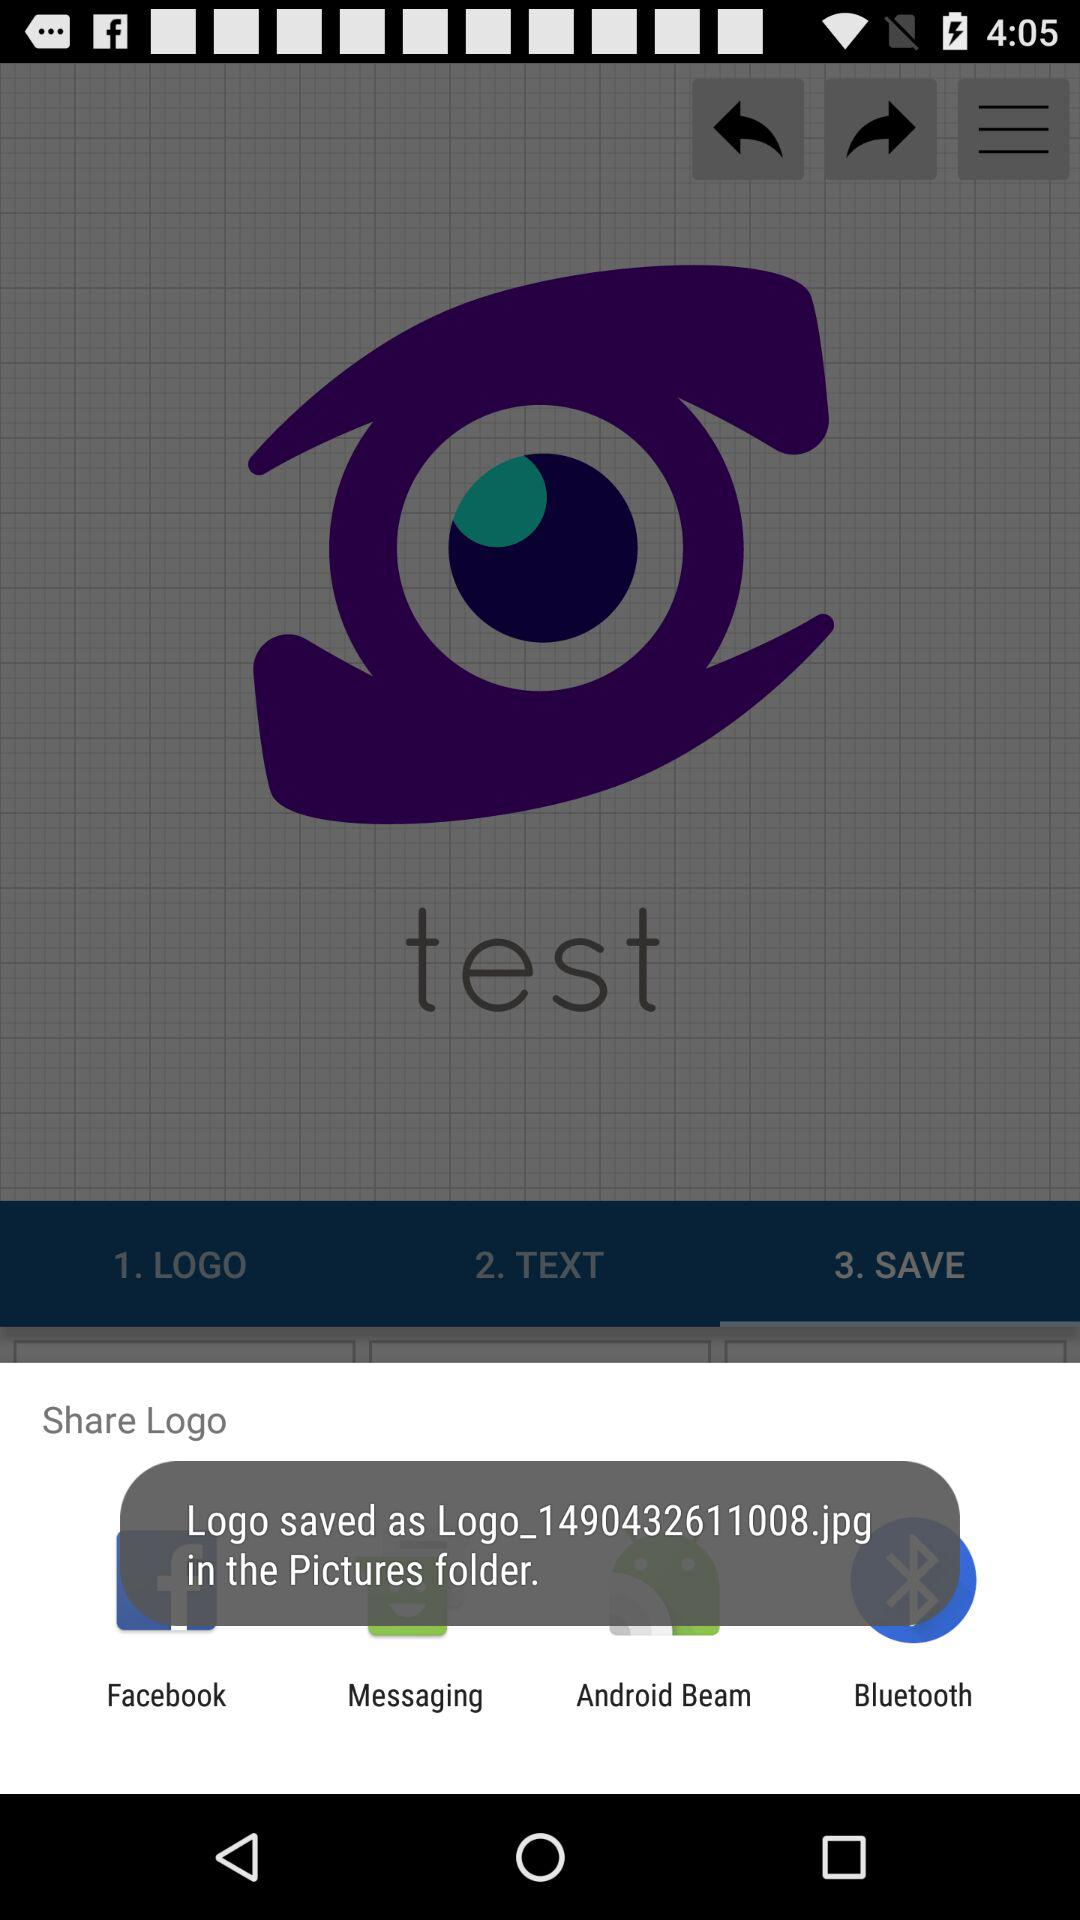In what folder logo has been saved? The logo has been saved in the "Pictures" folder. 